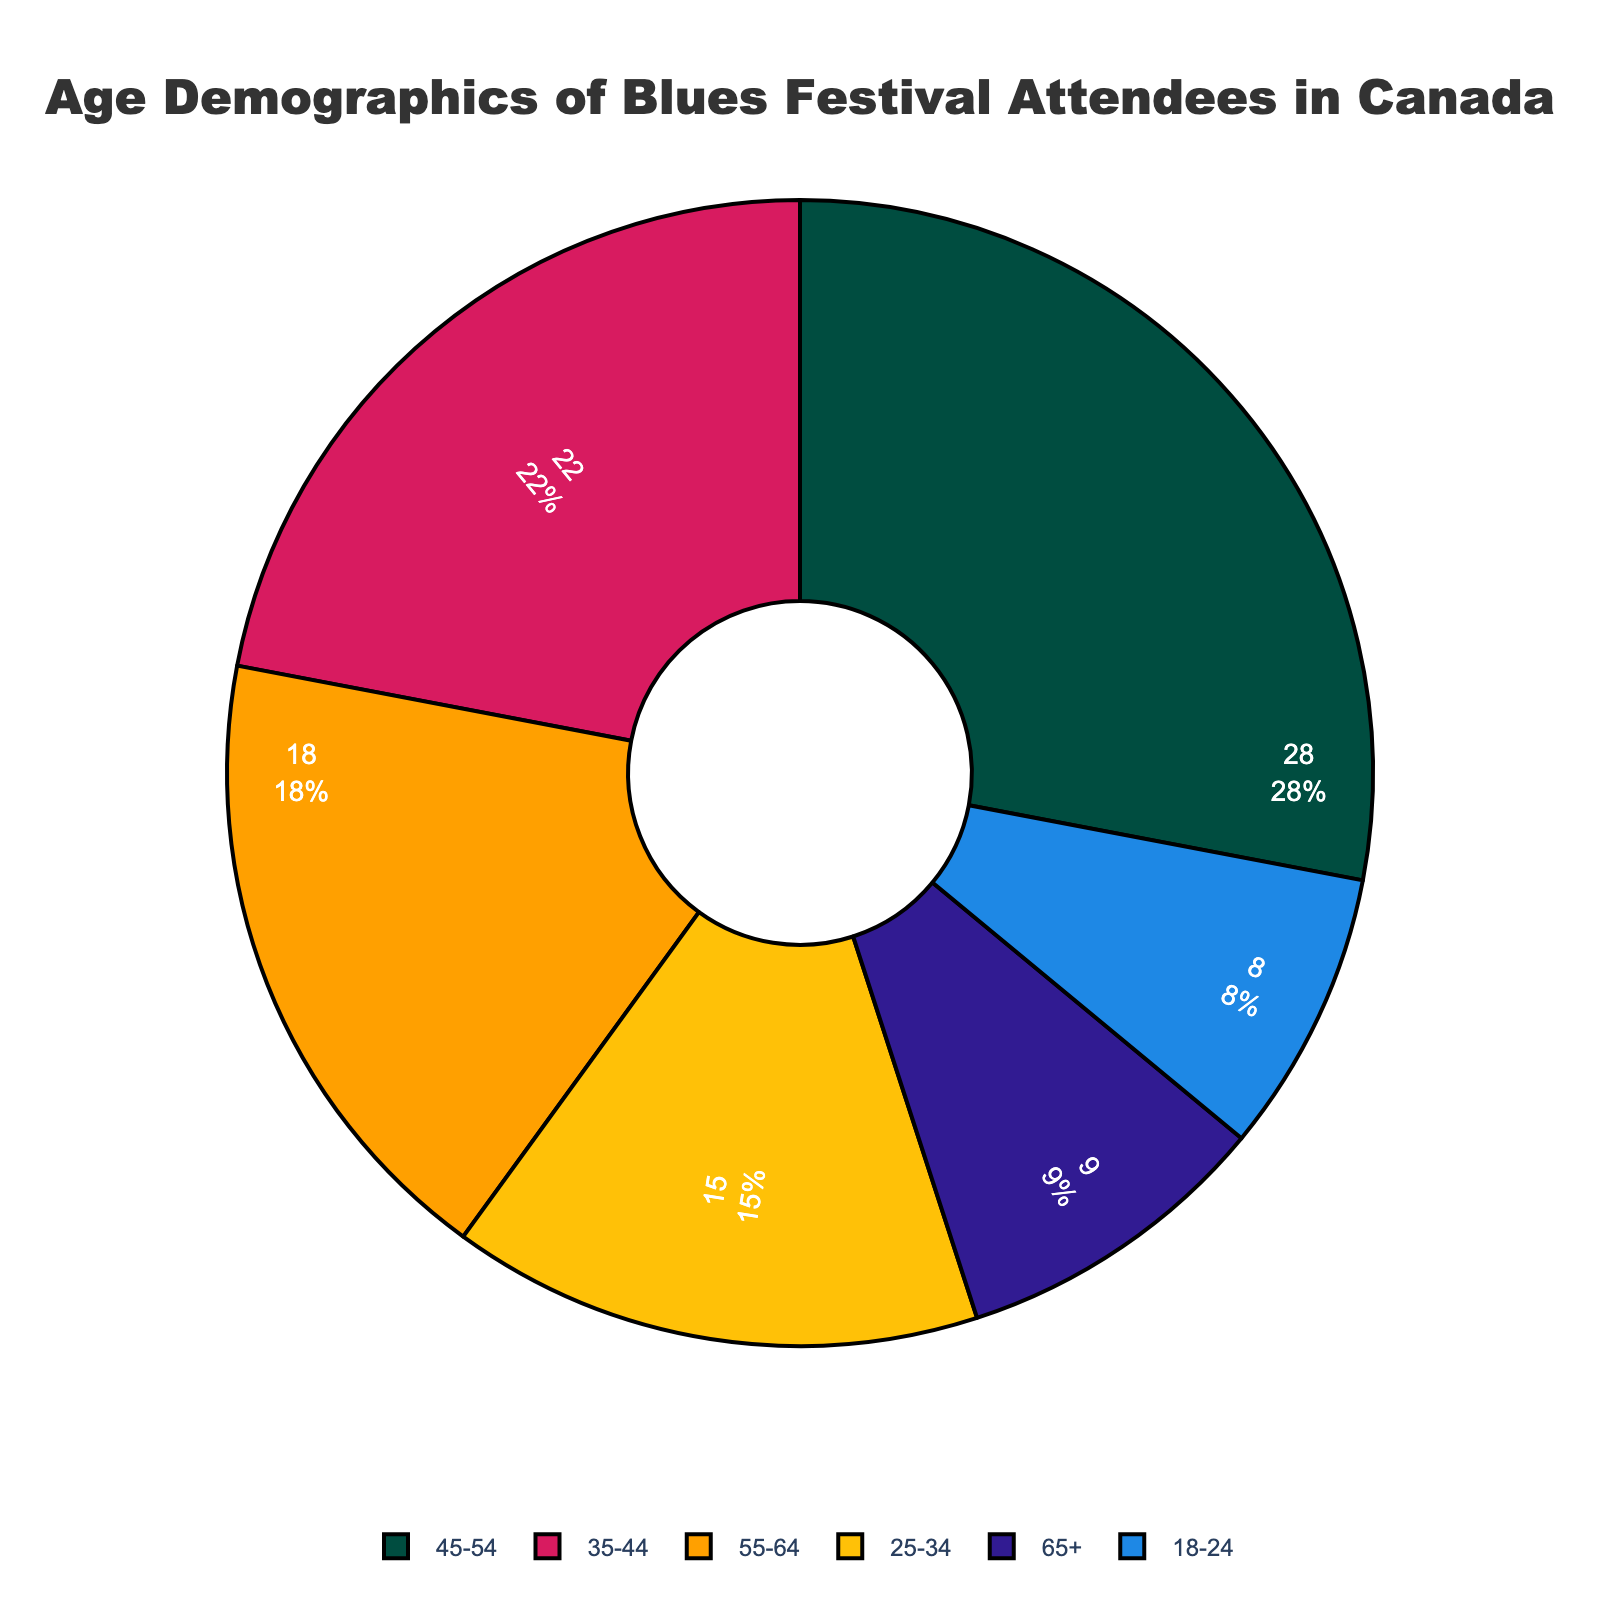Which age group has the highest percentage of attendees? The largest segment in the pie chart is marked "45-54", indicating that the 45-54 age group has the highest percentage.
Answer: 45-54 How much higher is the percentage of attendees aged 45-54 compared to those aged 65+? Subtract the percentage of the 65+ age group from the percentage of the 45-54 age group: 28% - 9% = 19%.
Answer: 19% What's the combined percentage of attendees aged 55 and above? Add the percentages for the 55-64 and 65+ age groups: 18% + 9% = 27%.
Answer: 27% Compare the percentages of attendees aged 18-24 and 25-34. Which is greater, and by how much? Subtract the percentage of the 18-24 age group from the percentage of the 25-34 age group: 15% - 8% = 7%. Therefore, the 25-34 age group is greater by 7%.
Answer: 25-34 by 7% What's the total percentage of attendees aged 24-44? Add the percentages for 18-24, 25-34, and 35-44 age groups: 8% + 15% + 22% = 45%.
Answer: 45% Which age group has the second highest percentage of attendees and what is that percentage? The pie chart shows that 35-44 has the next largest segment after 45-54, marked at 22%.
Answer: 35-44, 22% If you compared the smallest and the largest age group segments, which groups are they and what is the absolute difference in their percentages? The smallest age group is 18-24 (8%) and the largest is 45-54 (28%). The absolute difference is 28% - 8% = 20%.
Answer: 18-24 and 45-54, 20% What's the percentage difference between attendees aged 35-44 and 55-64? Subtract the percentage of the 55-64 age group from the percentage of the 35-44 age group: 22% - 18% = 4%.
Answer: 4% How many age groups are larger than 20%? From the pie chart, two age groups are larger than 20%: 35-44 (22%) and 45-54 (28%).
Answer: 2 